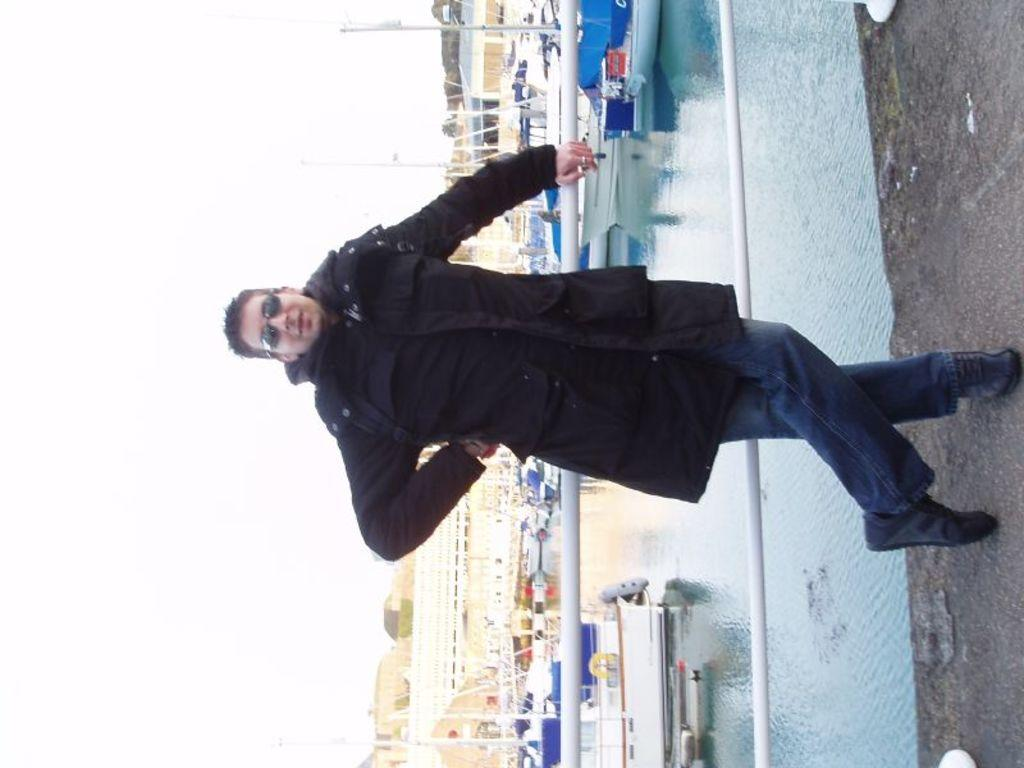What is the person in the image doing? The person is standing beside the railing. What can be seen in the distance on the water? There are boats on the ocean. What type of structures are visible in the image? There are houses visible in the image. What is visible above the houses and boats? The sky is visible in the image. What type of organization is responsible for the trail in the image? There is no trail present in the image, so it is not possible to determine which organization might be responsible for it. 